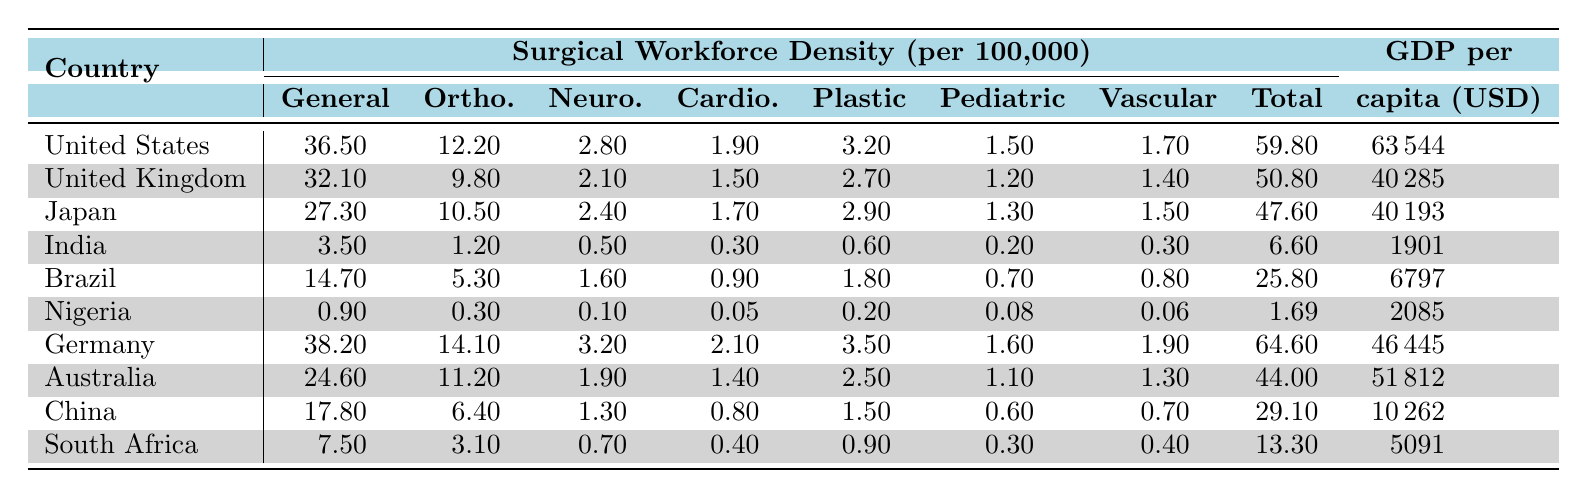What country has the highest density of general surgeons? The United States has the highest density of general surgeons at 36.5 per 100,000.
Answer: United States How many orthopedic surgeons are there per 100,000 in Germany? Germany has 14.1 orthopedic surgeons per 100,000.
Answer: 14.1 Which country has the lowest number of pediatric surgeons? Nigeria has the lowest number of pediatric surgeons, with only 0.08 per 100,000.
Answer: Nigeria What is the total number of surgeons per 100,000 in India? India has a total of 6.6 surgeons per 100,000.
Answer: 6.6 How does the total surgeon density in Australia compare to that in Brazil? Australia has 44.0 total surgeons per 100,000, which is higher than Brazil's 25.8.
Answer: Higher What is the difference in total surgeon density between the United States and South Africa? The United States has 59.8 total surgeons, while South Africa has 13.3. The difference is 59.8 - 13.3 = 46.5.
Answer: 46.5 Calculate the average number of neurosurgeons across all countries in the table. The total number of neurosurgeons is (2.8 + 2.1 + 2.4 + 0.5 + 1.6 + 0.1 + 3.2 + 1.9 + 1.3 + 0.7) = 16.6, and there are 10 countries. The average is 16.6 / 10 = 1.66.
Answer: 1.66 Is there a correlation between GDP per capita and total surgeon density? From the data, as GDP per capita increases, the total surgeon density also generally increases. For instance, the United States has the highest GDP and total surgeons.
Answer: Yes Which country has the highest density of vascular surgeons, and what is that density? Germany has the highest density of vascular surgeons at 1.9 per 100,000.
Answer: Germany, 1.9 What percentage of surgical specialties in the United Kingdom have a density greater than 1 per 100,000? The UK has six surgical specialties, and five of them have a density greater than 1. Therefore, 5 out of 6 specialties equals approximately 83.33%.
Answer: 83.33% 